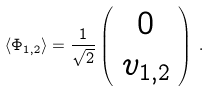Convert formula to latex. <formula><loc_0><loc_0><loc_500><loc_500>\langle \Phi _ { 1 , 2 } \rangle = \frac { 1 } { \sqrt { 2 } } \left ( \begin{array} { c } 0 \\ v _ { 1 , 2 } \end{array} \right ) \, .</formula> 